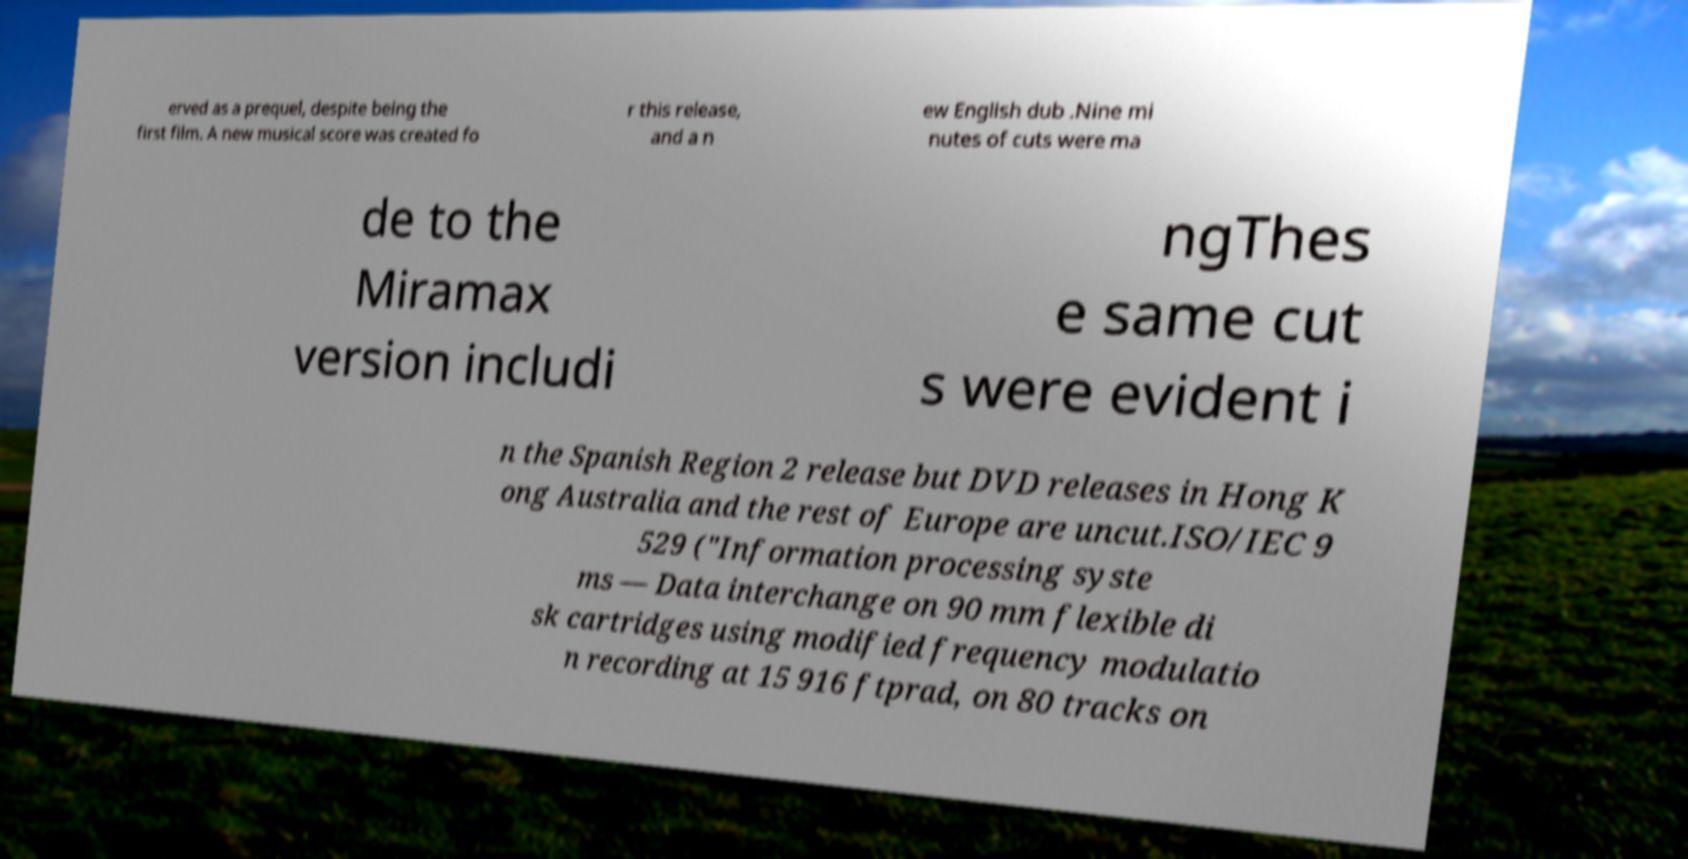Please read and relay the text visible in this image. What does it say? erved as a prequel, despite being the first film. A new musical score was created fo r this release, and a n ew English dub .Nine mi nutes of cuts were ma de to the Miramax version includi ngThes e same cut s were evident i n the Spanish Region 2 release but DVD releases in Hong K ong Australia and the rest of Europe are uncut.ISO/IEC 9 529 ("Information processing syste ms — Data interchange on 90 mm flexible di sk cartridges using modified frequency modulatio n recording at 15 916 ftprad, on 80 tracks on 